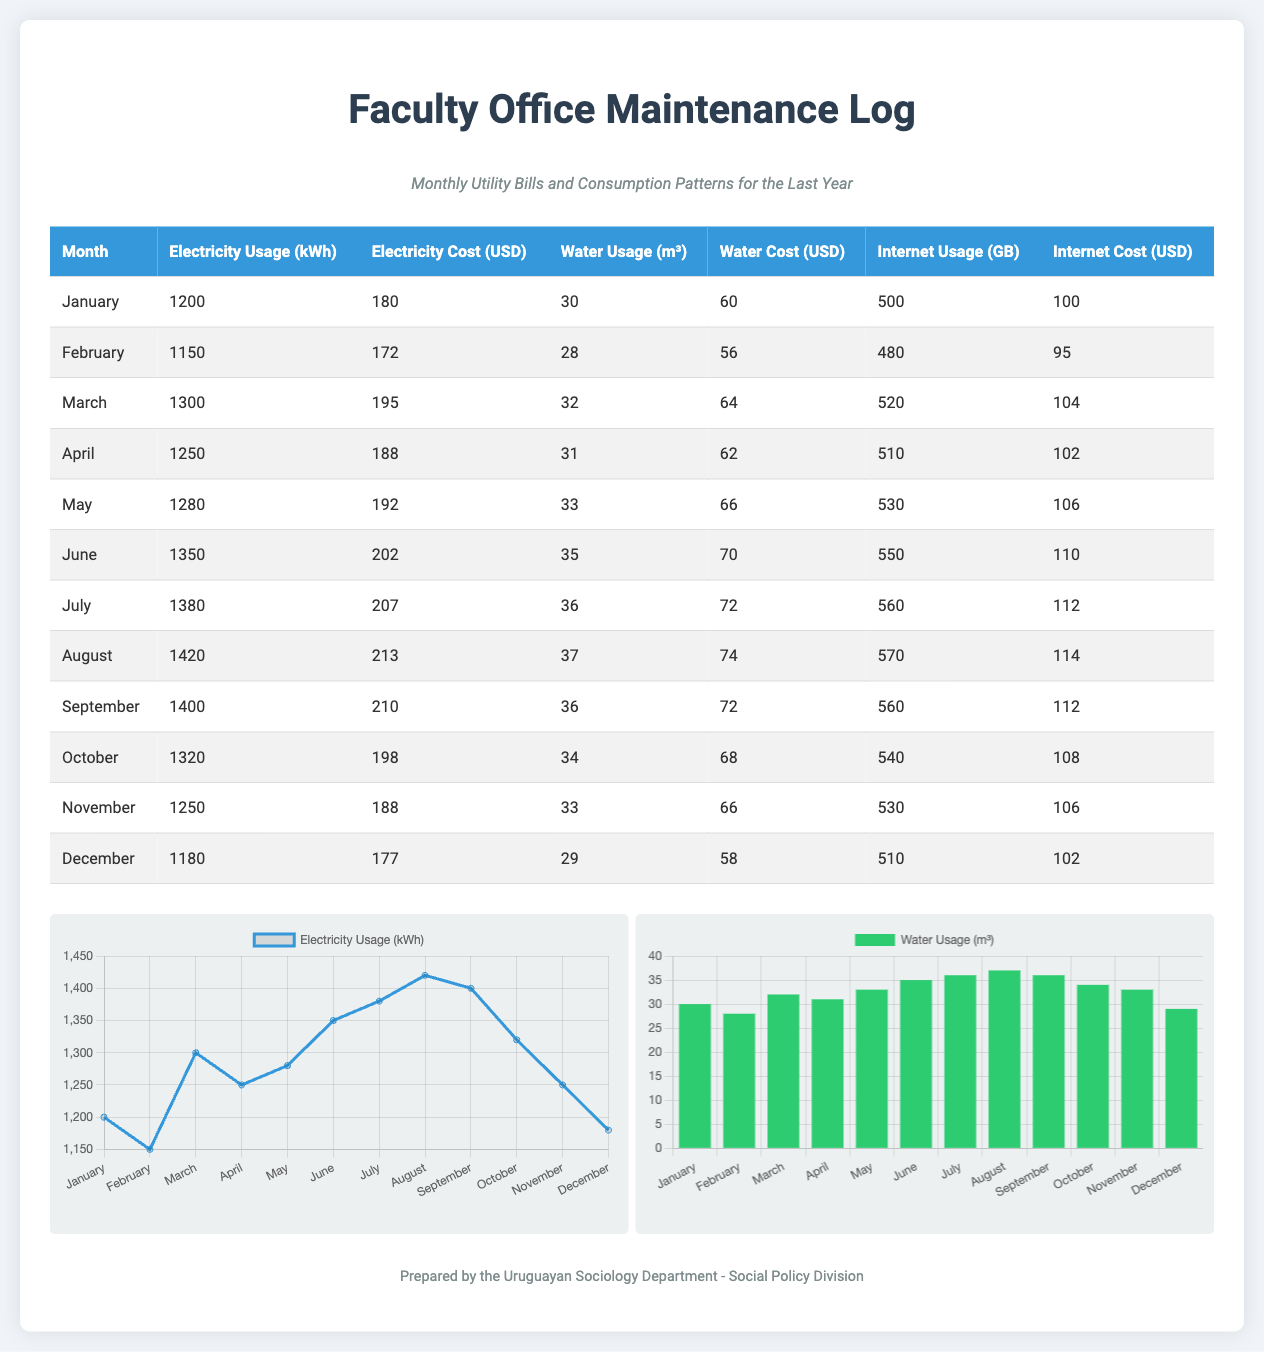What was the electricity usage in June? The electricity usage in June is noted in the table as 1350 kWh.
Answer: 1350 kWh Which month had the highest water cost? To determine the highest water cost, we compare the water costs listed, with August showing the highest cost at 74 USD.
Answer: 74 USD How much was the total electricity cost for the year? The total electricity cost is the sum of all monthly costs, which can be calculated as: 180 + 172 + 195 + 188 + 192 + 202 + 207 + 213 + 210 + 198 + 188 + 177 = 2290 USD.
Answer: 2290 USD In which month was electricity usage exactly 1250 kWh? The table indicates that electricity usage was 1250 kWh in both April and November, but the first instance is in April.
Answer: April What is the average water usage across all months? The average water usage can be calculated by summing the usage for each month (30 + 28 + 32 + 31 + 33 + 35 + 36 + 37 + 36 + 34 + 33 + 29 = 398) and dividing by 12 months; the result is approximately 33.17 m³ rounded to two decimal places.
Answer: 33.17 m³ Which month had the lowest internet usage? Comparing the internet usage across all months, we see that December had the lowest usage of 510 GB.
Answer: 510 GB What was the internet cost in April? In April, the internet cost is indicated as 102 USD in the table.
Answer: 102 USD What was the highest electricity usage recorded in a month? The highest electricity usage recorded was in August at 1420 kWh, as seen in the table.
Answer: 1420 kWh Which month had the highest water usage? The data shows July had the highest water usage at 36 m³.
Answer: 36 m³ 